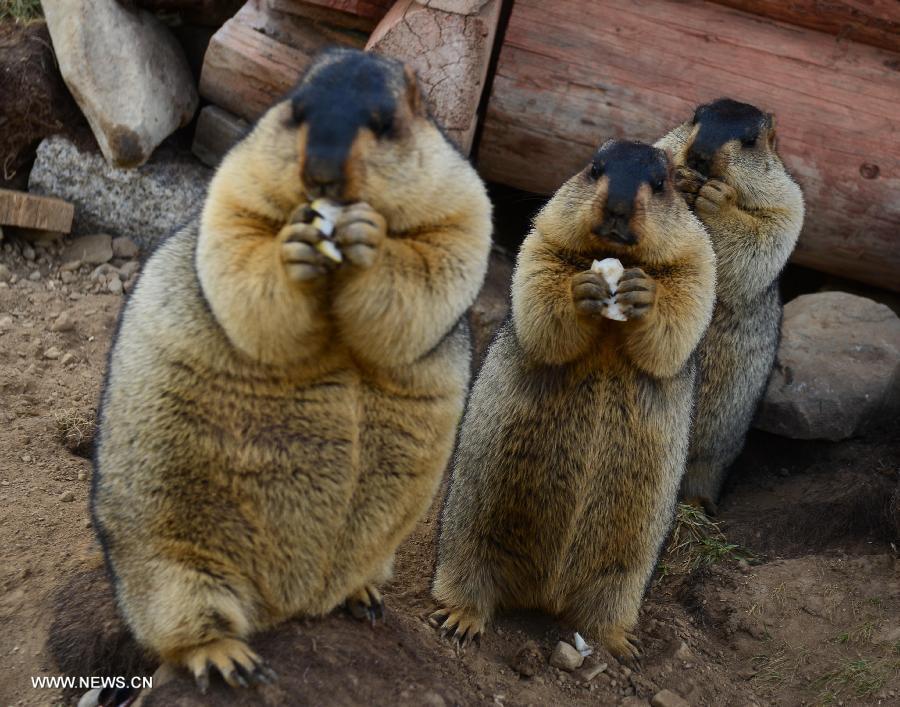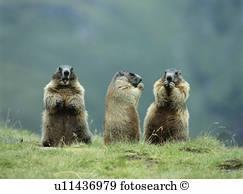The first image is the image on the left, the second image is the image on the right. Examine the images to the left and right. Is the description "An image shows three upright marmots facing the same general direction and clutching food." accurate? Answer yes or no. Yes. 